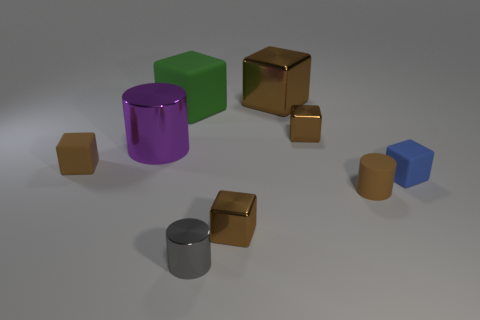How many brown blocks must be subtracted to get 2 brown blocks? 2 Subtract all blue cylinders. How many brown blocks are left? 4 Subtract all large metallic blocks. How many blocks are left? 5 Subtract 2 blocks. How many blocks are left? 4 Add 1 small blue rubber things. How many objects exist? 10 Subtract all blue cubes. How many cubes are left? 5 Subtract all blue cylinders. Subtract all cyan blocks. How many cylinders are left? 3 Subtract all blocks. How many objects are left? 3 Subtract all tiny blue matte things. Subtract all tiny metallic objects. How many objects are left? 5 Add 5 small metallic cubes. How many small metallic cubes are left? 7 